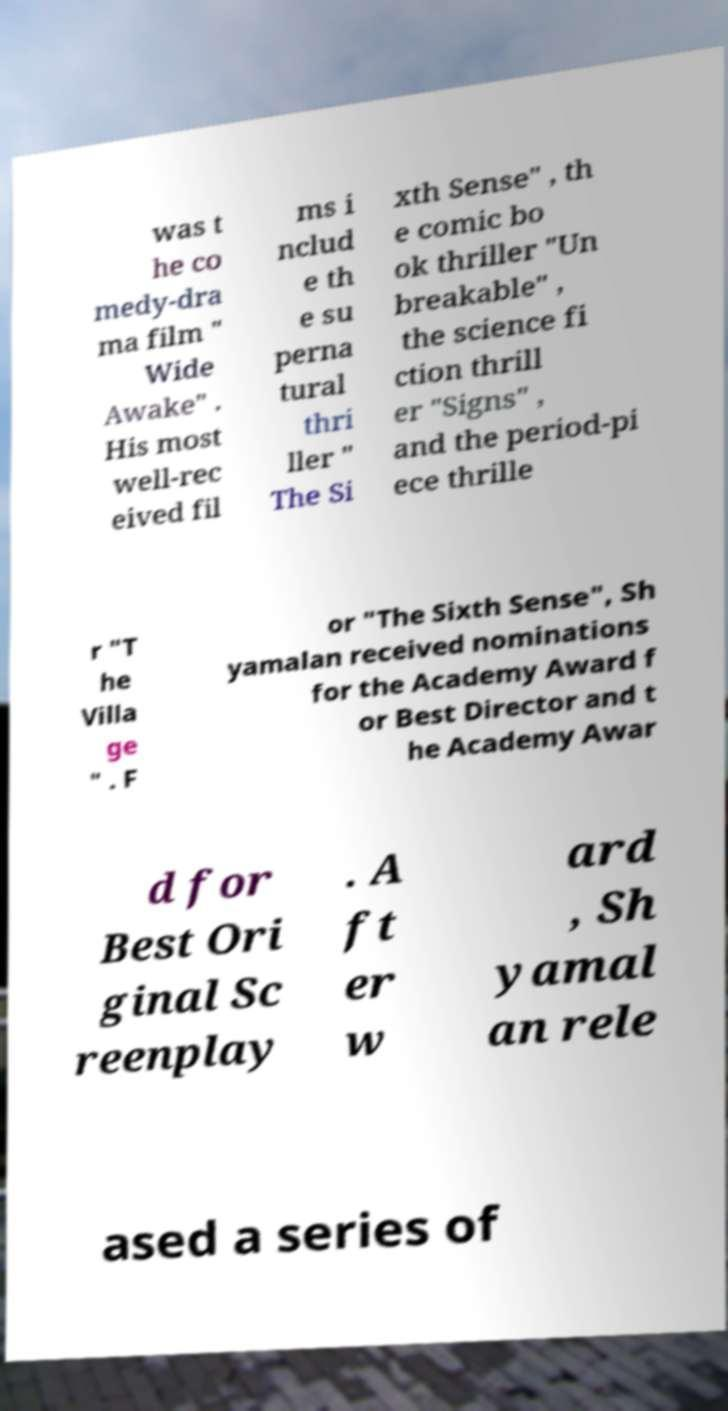Please read and relay the text visible in this image. What does it say? was t he co medy-dra ma film " Wide Awake" . His most well-rec eived fil ms i nclud e th e su perna tural thri ller " The Si xth Sense" , th e comic bo ok thriller "Un breakable" , the science fi ction thrill er "Signs" , and the period-pi ece thrille r "T he Villa ge " . F or "The Sixth Sense", Sh yamalan received nominations for the Academy Award f or Best Director and t he Academy Awar d for Best Ori ginal Sc reenplay . A ft er w ard , Sh yamal an rele ased a series of 